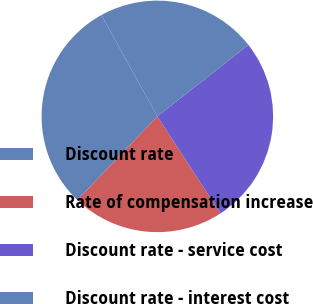<chart> <loc_0><loc_0><loc_500><loc_500><pie_chart><fcel>Discount rate<fcel>Rate of compensation increase<fcel>Discount rate - service cost<fcel>Discount rate - interest cost<nl><fcel>29.83%<fcel>21.31%<fcel>26.42%<fcel>22.44%<nl></chart> 